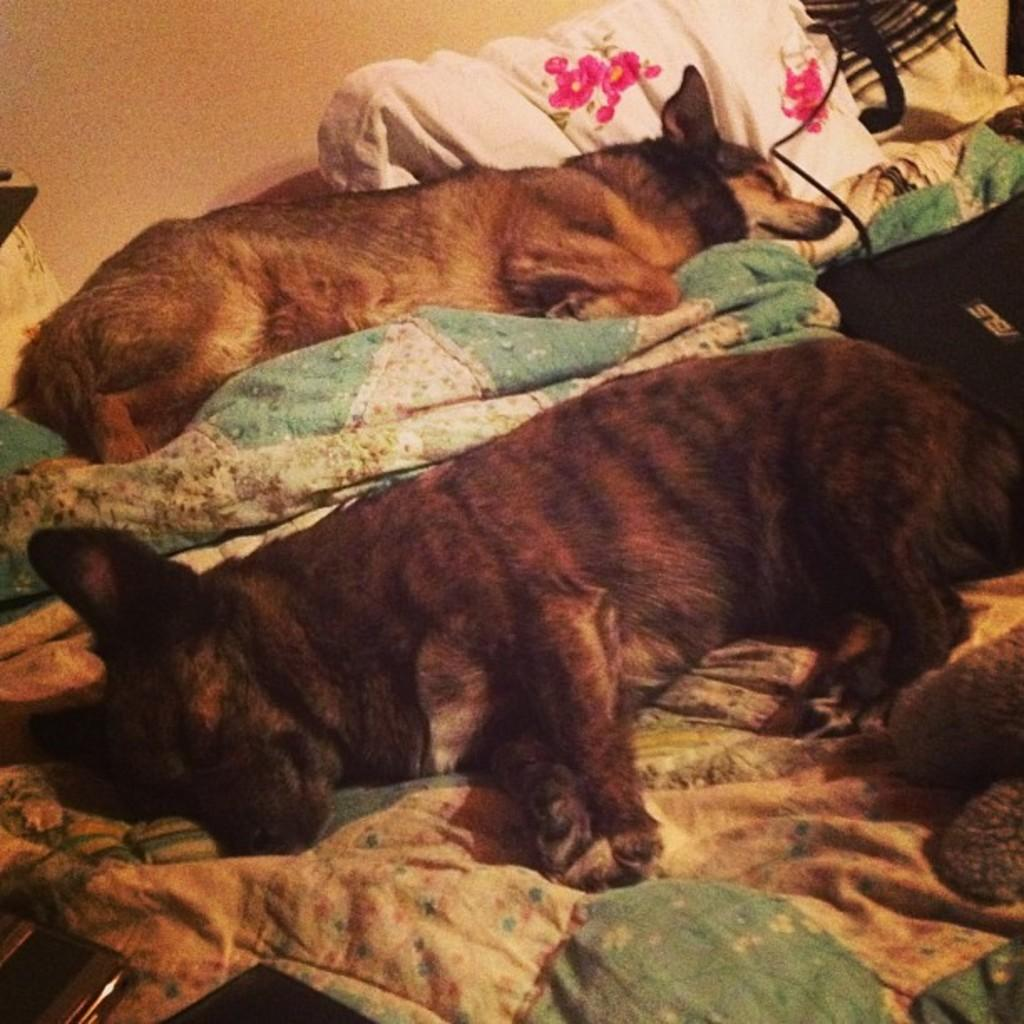How many dogs are present in the image? There are two dogs in the image. What are the dogs doing in the image? The dogs are laying on a cloth. What else can be seen on the cloth besides the dogs? There are items on the cloth. What is visible behind the dogs in the image? There is a wall behind the dogs. What type of scent can be detected from the stew in the image? There is no stew present in the image, so no scent can be detected. How many letters are visible on the cloth in the image? There is no mention of letters on the cloth in the provided facts, so we cannot determine their presence or quantity. 